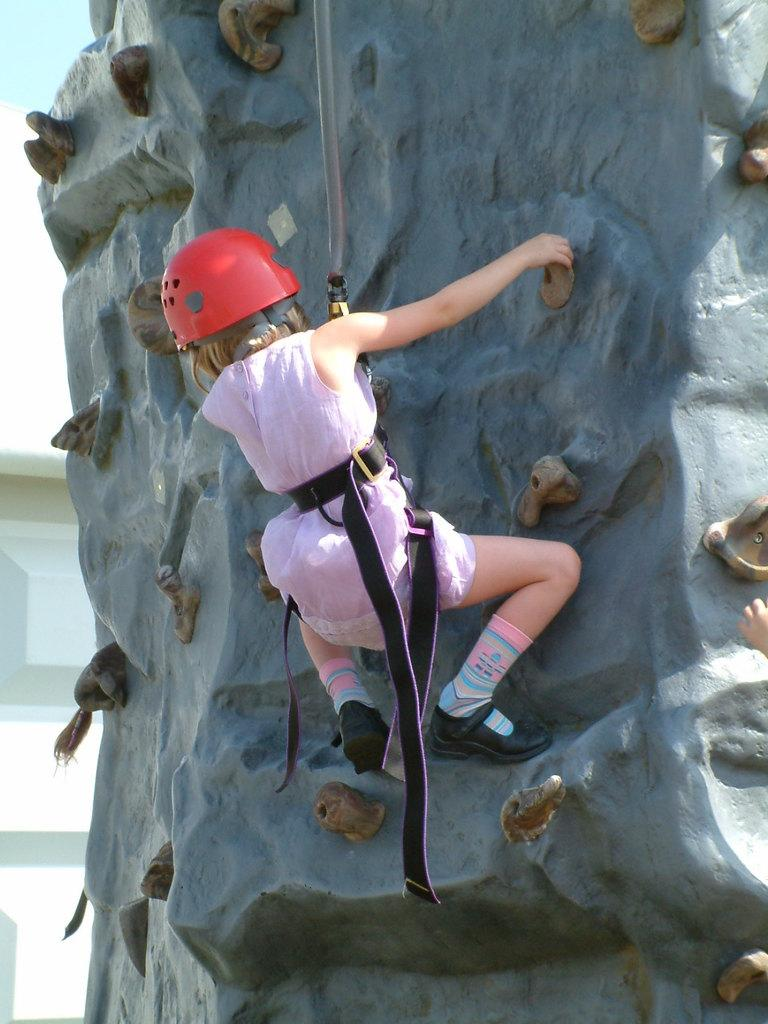What is the person in the image doing? The person is sport climbing. What type of clothing is the person wearing? The person is wearing a pink dress, a red helmet, and black shoes. What can be seen in the background of the image? There is a white door in the background of the image. What action does the person take after completing their journey in the image? There is no journey mentioned in the image, as the person is sport climbing. The image only shows the person in the act of climbing. 